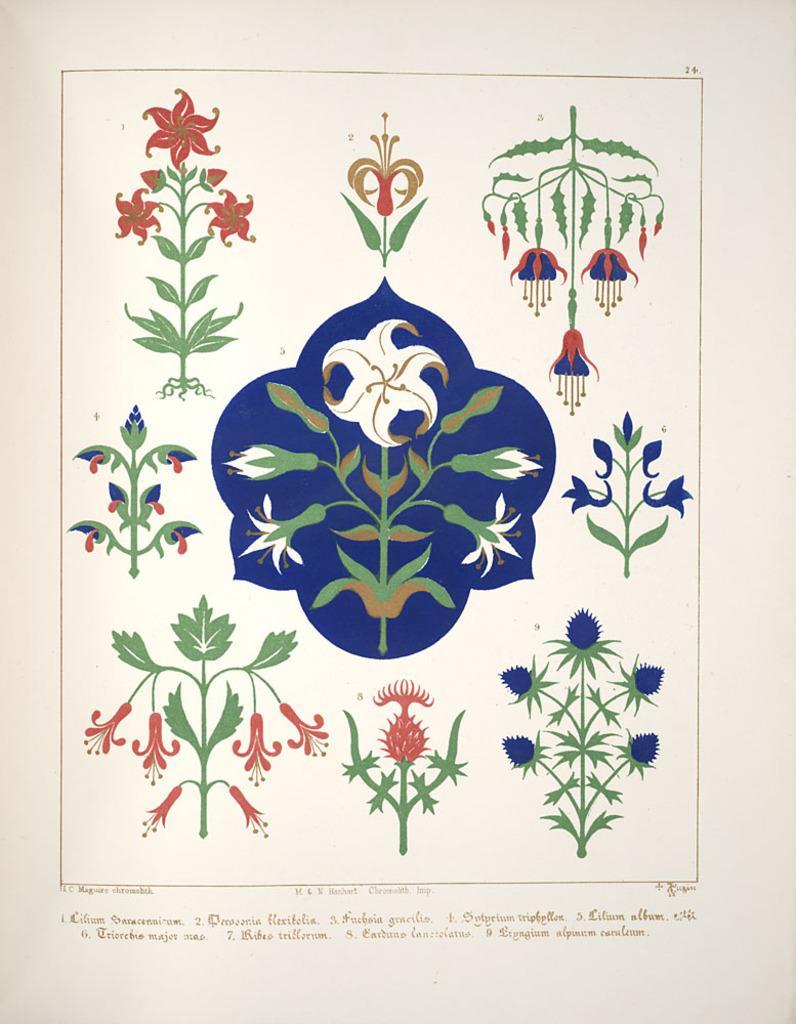In one or two sentences, can you explain what this image depicts? In this picture we can see paintings and text.  